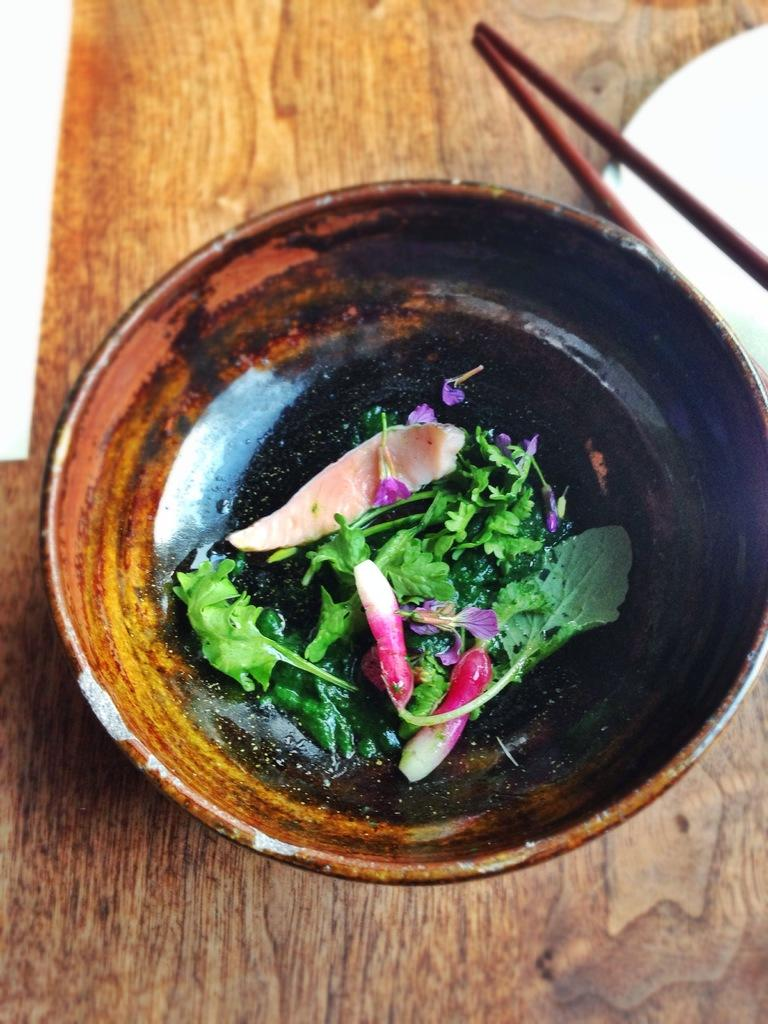What is present in the image? There is a bowl in the image. What is inside the bowl? There are leaves in the bowl. What type of lumber can be seen in the scene? There is no lumber present in the image; it only features a bowl with leaves. 